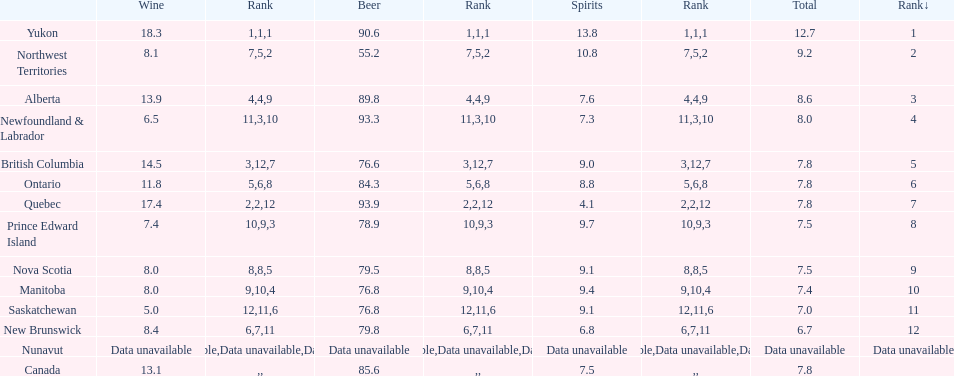Who drank more beer, quebec or northwest territories? Quebec. 